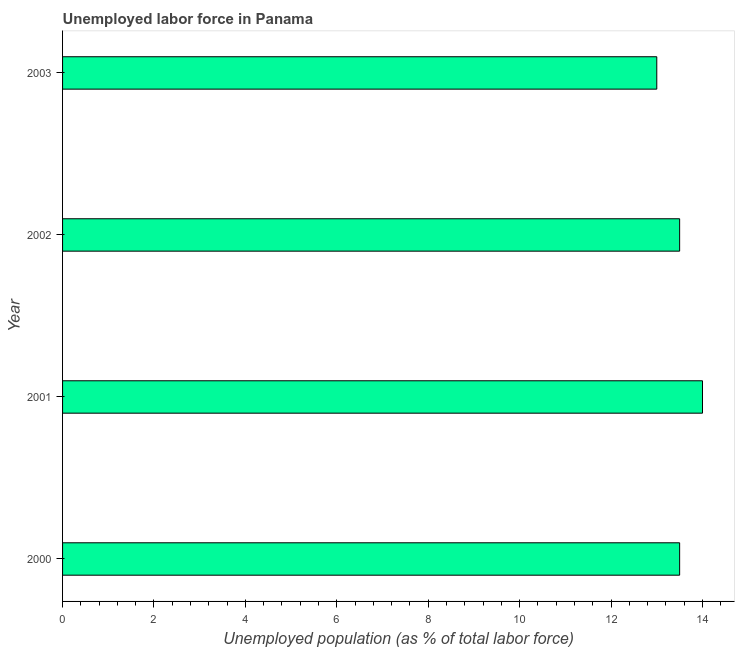Does the graph contain any zero values?
Your response must be concise. No. What is the title of the graph?
Provide a succinct answer. Unemployed labor force in Panama. What is the label or title of the X-axis?
Provide a short and direct response. Unemployed population (as % of total labor force). What is the label or title of the Y-axis?
Give a very brief answer. Year. What is the total unemployed population in 2002?
Your response must be concise. 13.5. Across all years, what is the maximum total unemployed population?
Offer a very short reply. 14. Across all years, what is the minimum total unemployed population?
Your response must be concise. 13. What is the sum of the total unemployed population?
Give a very brief answer. 54. What is the difference between the total unemployed population in 2002 and 2003?
Offer a very short reply. 0.5. What is the average total unemployed population per year?
Your response must be concise. 13.5. Do a majority of the years between 2000 and 2001 (inclusive) have total unemployed population greater than 2.8 %?
Ensure brevity in your answer.  Yes. Is the total unemployed population in 2002 less than that in 2003?
Ensure brevity in your answer.  No. What is the difference between the highest and the second highest total unemployed population?
Keep it short and to the point. 0.5. What is the difference between the highest and the lowest total unemployed population?
Offer a terse response. 1. How many bars are there?
Your answer should be compact. 4. Are all the bars in the graph horizontal?
Ensure brevity in your answer.  Yes. How many years are there in the graph?
Ensure brevity in your answer.  4. What is the difference between two consecutive major ticks on the X-axis?
Make the answer very short. 2. What is the Unemployed population (as % of total labor force) in 2003?
Your answer should be compact. 13. What is the difference between the Unemployed population (as % of total labor force) in 2000 and 2001?
Make the answer very short. -0.5. What is the difference between the Unemployed population (as % of total labor force) in 2000 and 2002?
Keep it short and to the point. 0. What is the ratio of the Unemployed population (as % of total labor force) in 2000 to that in 2002?
Offer a very short reply. 1. What is the ratio of the Unemployed population (as % of total labor force) in 2000 to that in 2003?
Your answer should be very brief. 1.04. What is the ratio of the Unemployed population (as % of total labor force) in 2001 to that in 2002?
Your answer should be very brief. 1.04. What is the ratio of the Unemployed population (as % of total labor force) in 2001 to that in 2003?
Provide a short and direct response. 1.08. What is the ratio of the Unemployed population (as % of total labor force) in 2002 to that in 2003?
Make the answer very short. 1.04. 